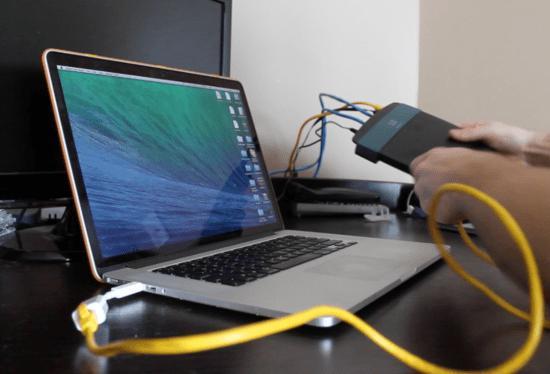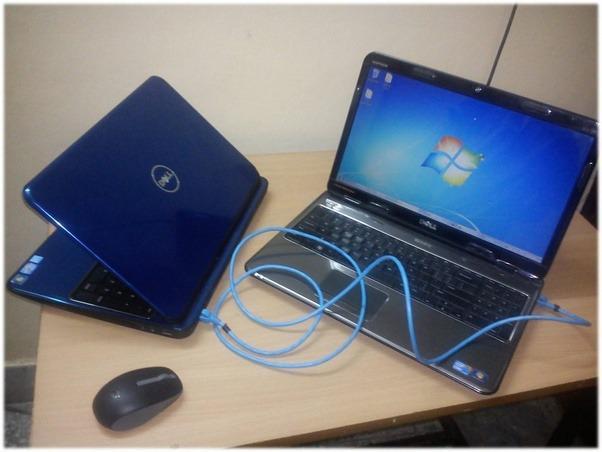The first image is the image on the left, the second image is the image on the right. Considering the images on both sides, is "One image contains twice as many laptops as the other image, and the other image features a rightward-facing laptop with a blue-and-green wave on its screen." valid? Answer yes or no. Yes. The first image is the image on the left, the second image is the image on the right. Assess this claim about the two images: "The left and right image contains the same number of laptops.". Correct or not? Answer yes or no. No. 